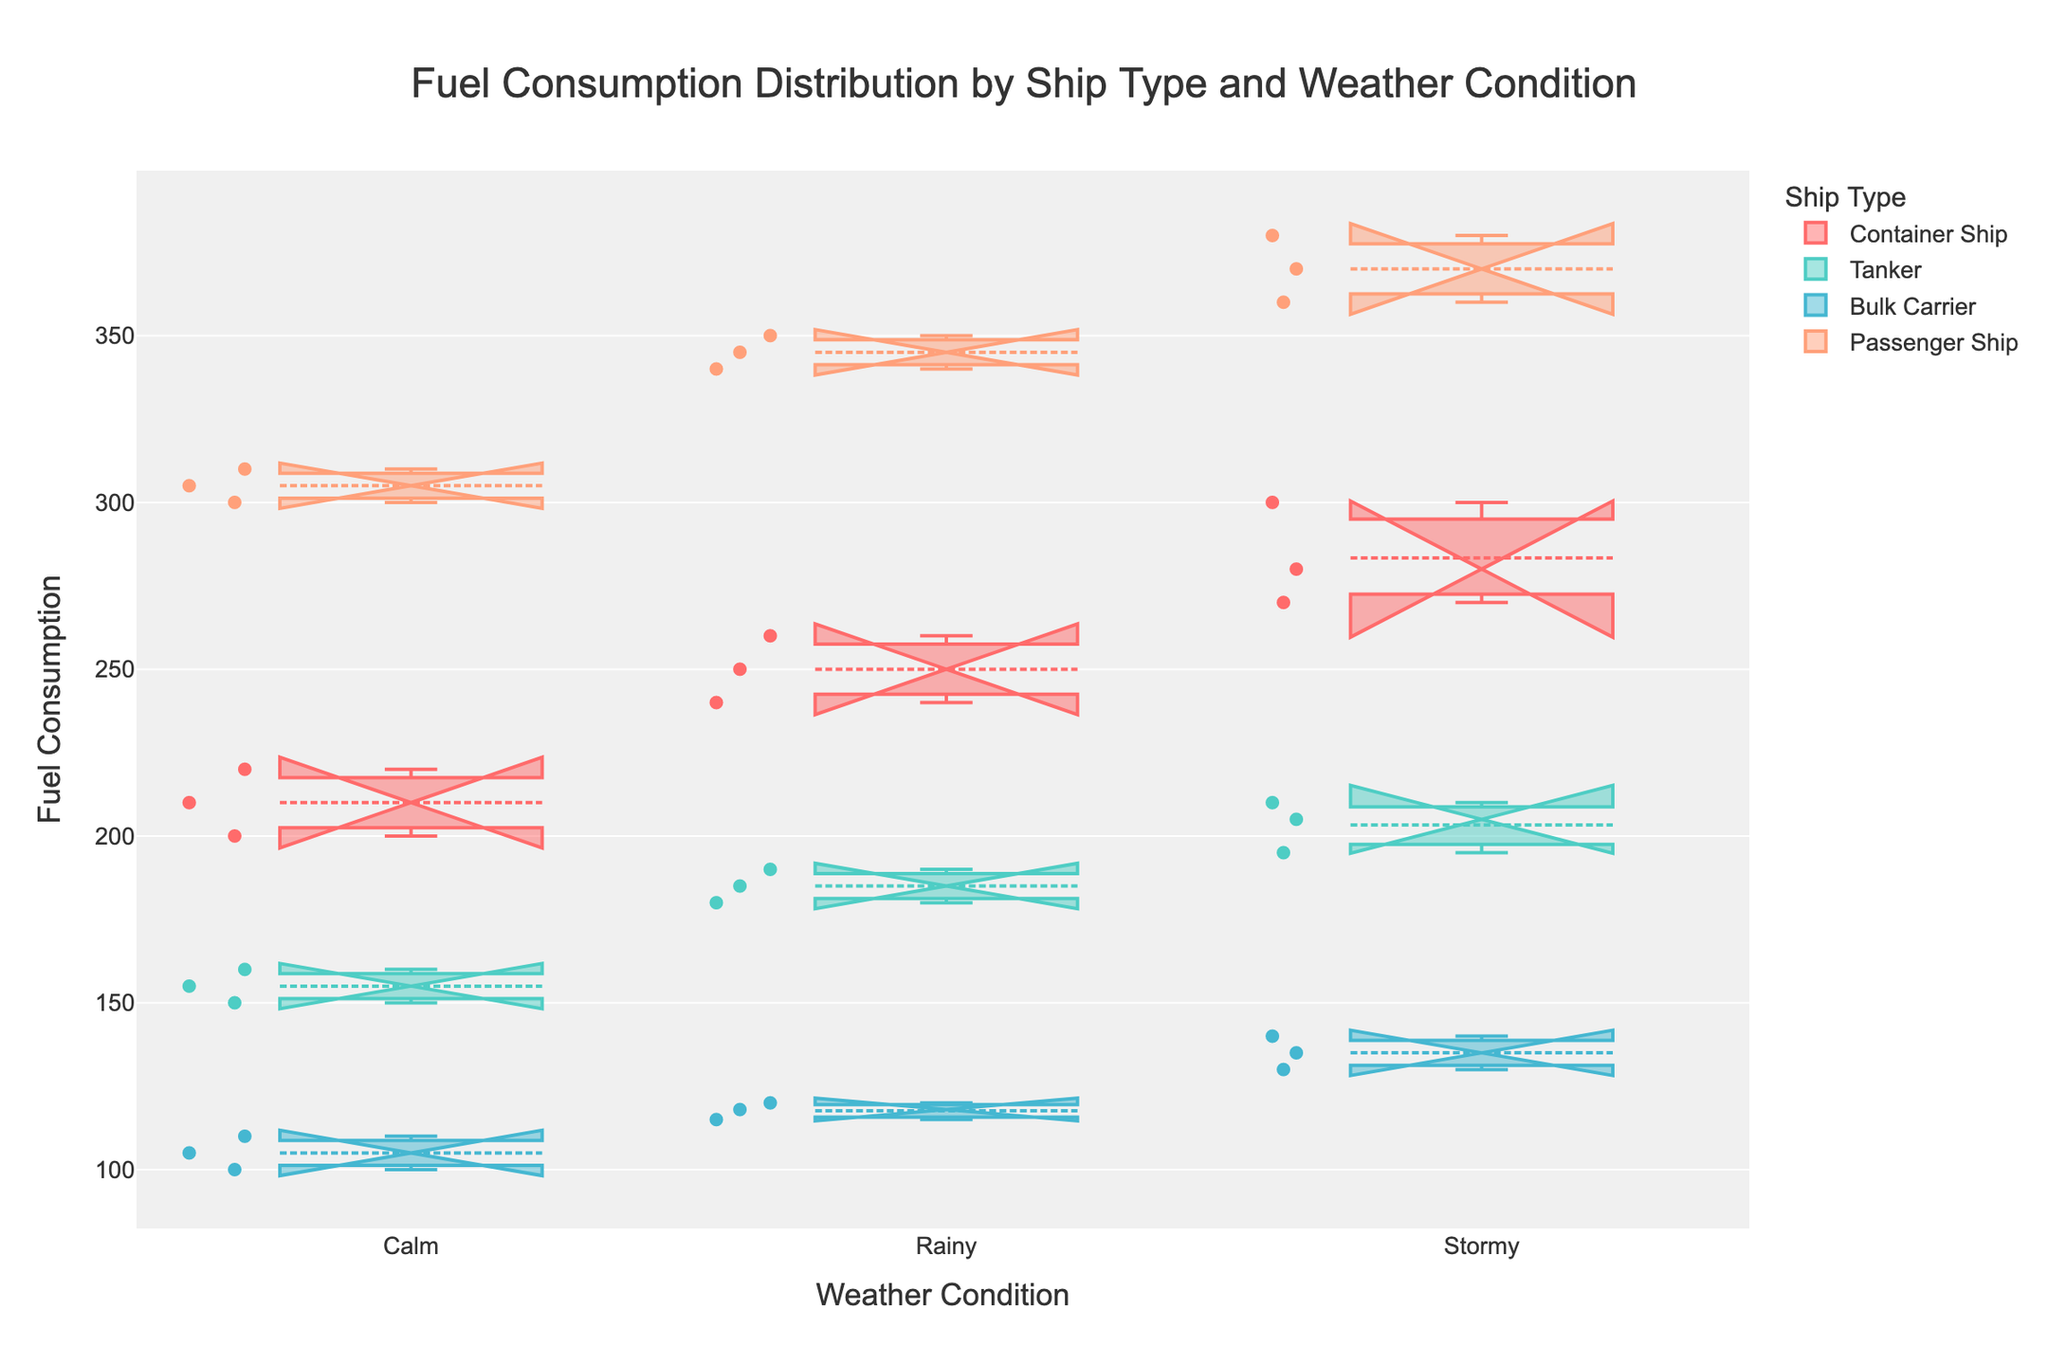What is the title of the figure? The title of the figure is usually displayed at the top. In this case, it is "Fuel Consumption Distribution by Ship Type and Weather Condition".
Answer: Fuel Consumption Distribution by Ship Type and Weather Condition Which ship type has the highest median fuel consumption under calm weather conditions? Look at the notches and medians within the box plots under calm weather conditions. The ship type with the highest median fuel consumption here is the one with the highest median line under the calm condition, which is the Passenger Ship.
Answer: Passenger Ship How many different weather conditions are depicted in the figure? The number of ticks on the x-axis represents the different weather conditions. Here, we see three categories: Calm, Rainy, and Stormy.
Answer: Three Which ship type shows the greatest variability in fuel consumption under stormy weather conditions? Variability in box plots is indicated by the length of the boxes and whiskers. For stormy conditions, the Passenger Ship has the longest range, showing the greatest variability.
Answer: Passenger Ship What is the median fuel consumption of the Tanker under rainy conditions? The median of the Tanker under rainy conditions is the line inside the box of the Tanker for the Rainy category. This value is at 185.
Answer: 185 Which ship type has the smallest interquartile range (IQR) under calm weather conditions? The interquartile range (IQR) is the distance between the first and third quartiles. The Bulk Carrier has the smallest IQR under calm conditions, indicating less spread in the middle 50% of the data.
Answer: Bulk Carrier Compare the median fuel consumption of Container Ships and Bulk Carriers under stormy conditions. Which one is higher? Look at the notches (medians) for both Container Ships and Bulk Carriers under stormy conditions. The Container Ships have a higher median compared to Bulk Carriers.
Answer: Container Ships Which ship type is more affected by increasing weather severity (from Calm to Stormy) in terms of an increase in median fuel consumption? Compare the increase in medians for each ship type from calm to stormy conditions. The Passenger Ship shows the greatest increase in median fuel consumption.
Answer: Passenger Ship Is there any ship type whose fuel consumption remains relatively stable across different weather conditions? Look at the notches (medians) of each ship type across different weather conditions. The Tanker appears to have medians that are relatively close together, indicating more stable fuel consumption.
Answer: Tanker What can be inferred about the fuel consumption of Bulk Carriers under rainy conditions compared to calm and stormy conditions? For the Bulk Carrier, compare the median values under each weather condition. The median fuel consumption under rainy conditions is slightly higher than under calm conditions and lower than under stormy conditions.
Answer: Higher than calm, lower than stormy 